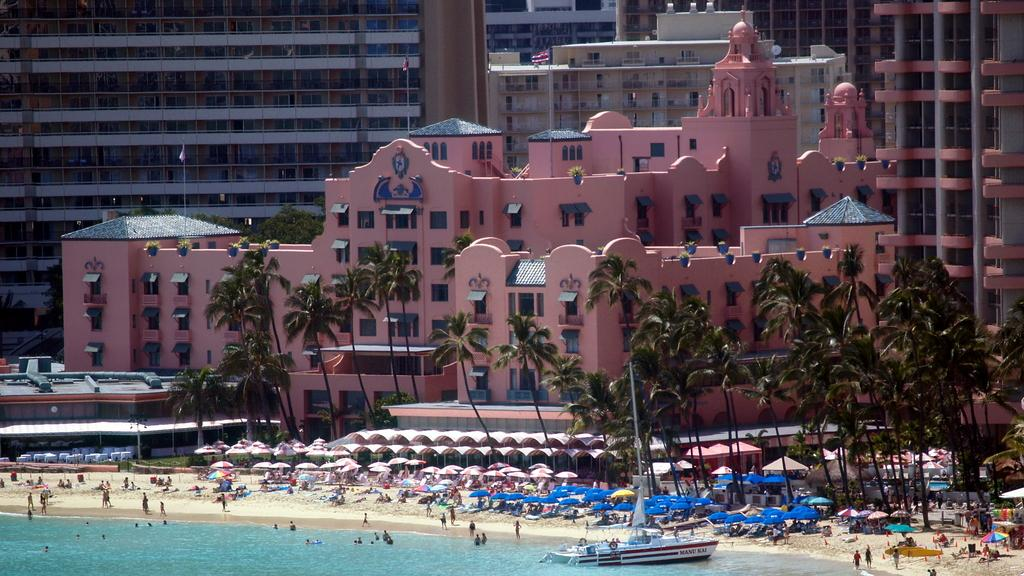What type of structures can be seen in the image? There are buildings in the image. What additional features are present in the image? There are flags, trees, umbrellas, tents, and people on the seashore visible in the image. Can you describe the natural elements in the image? There are trees and a boat on the sea in the image. What is visible in the sky? The sky is visible in the image. What type of recreational activity might be taking place in the image? The presence of tents and people on the seashore suggests that a beach or outdoor event might be happening. What organization is responsible for the note left on the grandfather's desk in the image? There is no mention of a note or a grandfather in the image, so it is not possible to answer this question. 